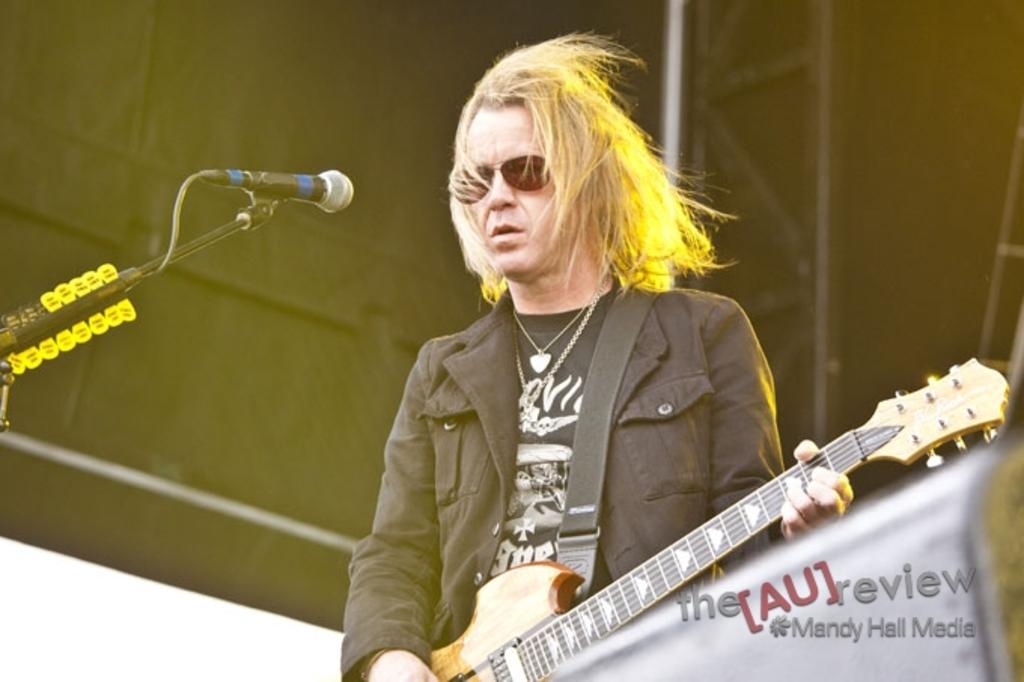What is the man in the image doing? The man is playing a guitar. How is the man positioned in the image? The man is standing. What object is near the man in the image? There is a microphone near the man. What can be seen in the background of the image? There are skis and poles in the background of the image. What type of farm animals can be seen in the image? There are no farm animals present in the image. How does the man's behavior change when he is playing the guitar? The image does not show any change in the man's behavior while playing the guitar, as it is a still image. 